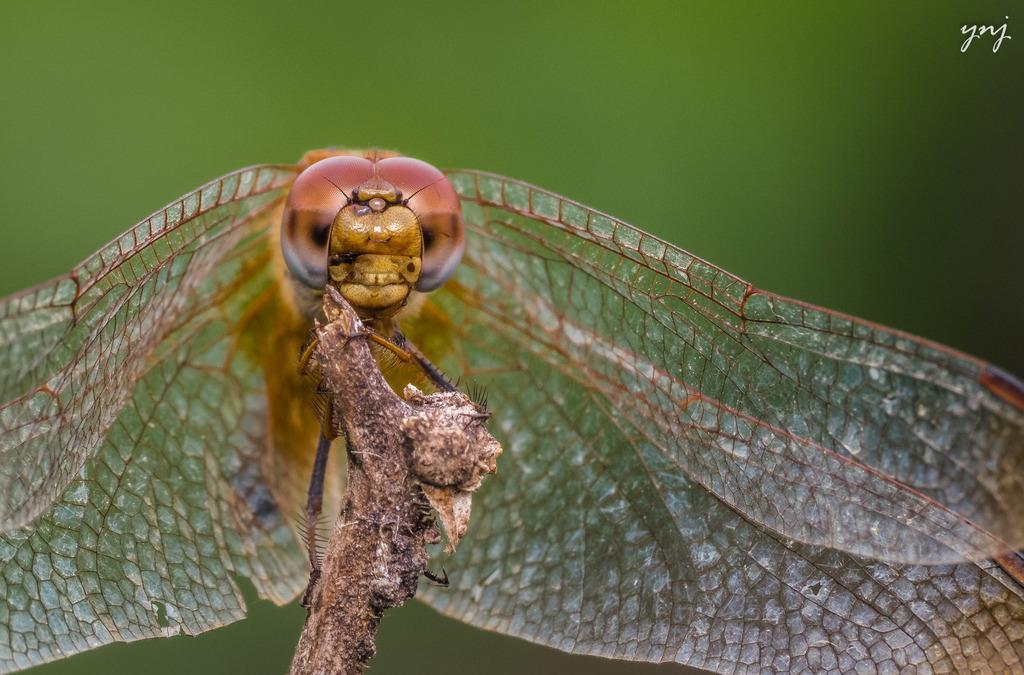Can you describe this image briefly? In this image I can see the dragon fly on the dried plant and there is a blurred background. 